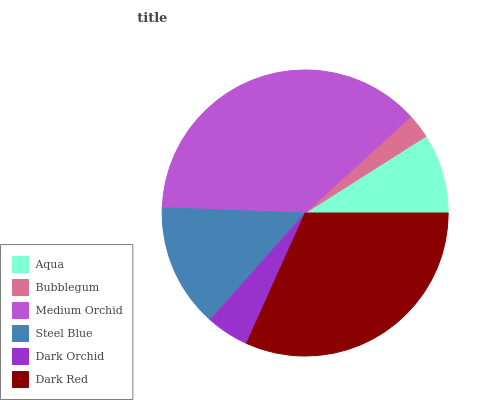Is Bubblegum the minimum?
Answer yes or no. Yes. Is Medium Orchid the maximum?
Answer yes or no. Yes. Is Medium Orchid the minimum?
Answer yes or no. No. Is Bubblegum the maximum?
Answer yes or no. No. Is Medium Orchid greater than Bubblegum?
Answer yes or no. Yes. Is Bubblegum less than Medium Orchid?
Answer yes or no. Yes. Is Bubblegum greater than Medium Orchid?
Answer yes or no. No. Is Medium Orchid less than Bubblegum?
Answer yes or no. No. Is Steel Blue the high median?
Answer yes or no. Yes. Is Aqua the low median?
Answer yes or no. Yes. Is Aqua the high median?
Answer yes or no. No. Is Bubblegum the low median?
Answer yes or no. No. 